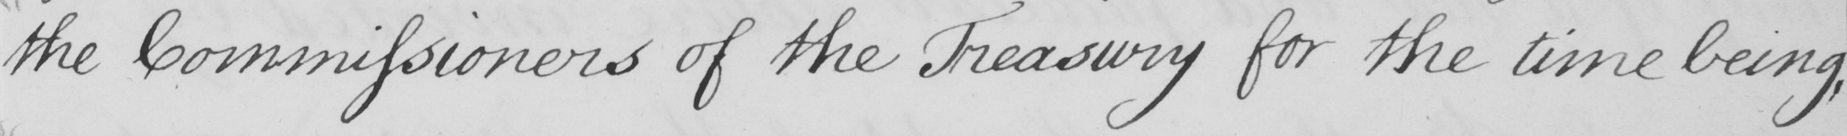What does this handwritten line say? the Commissioners of the Treasury for the time being , 